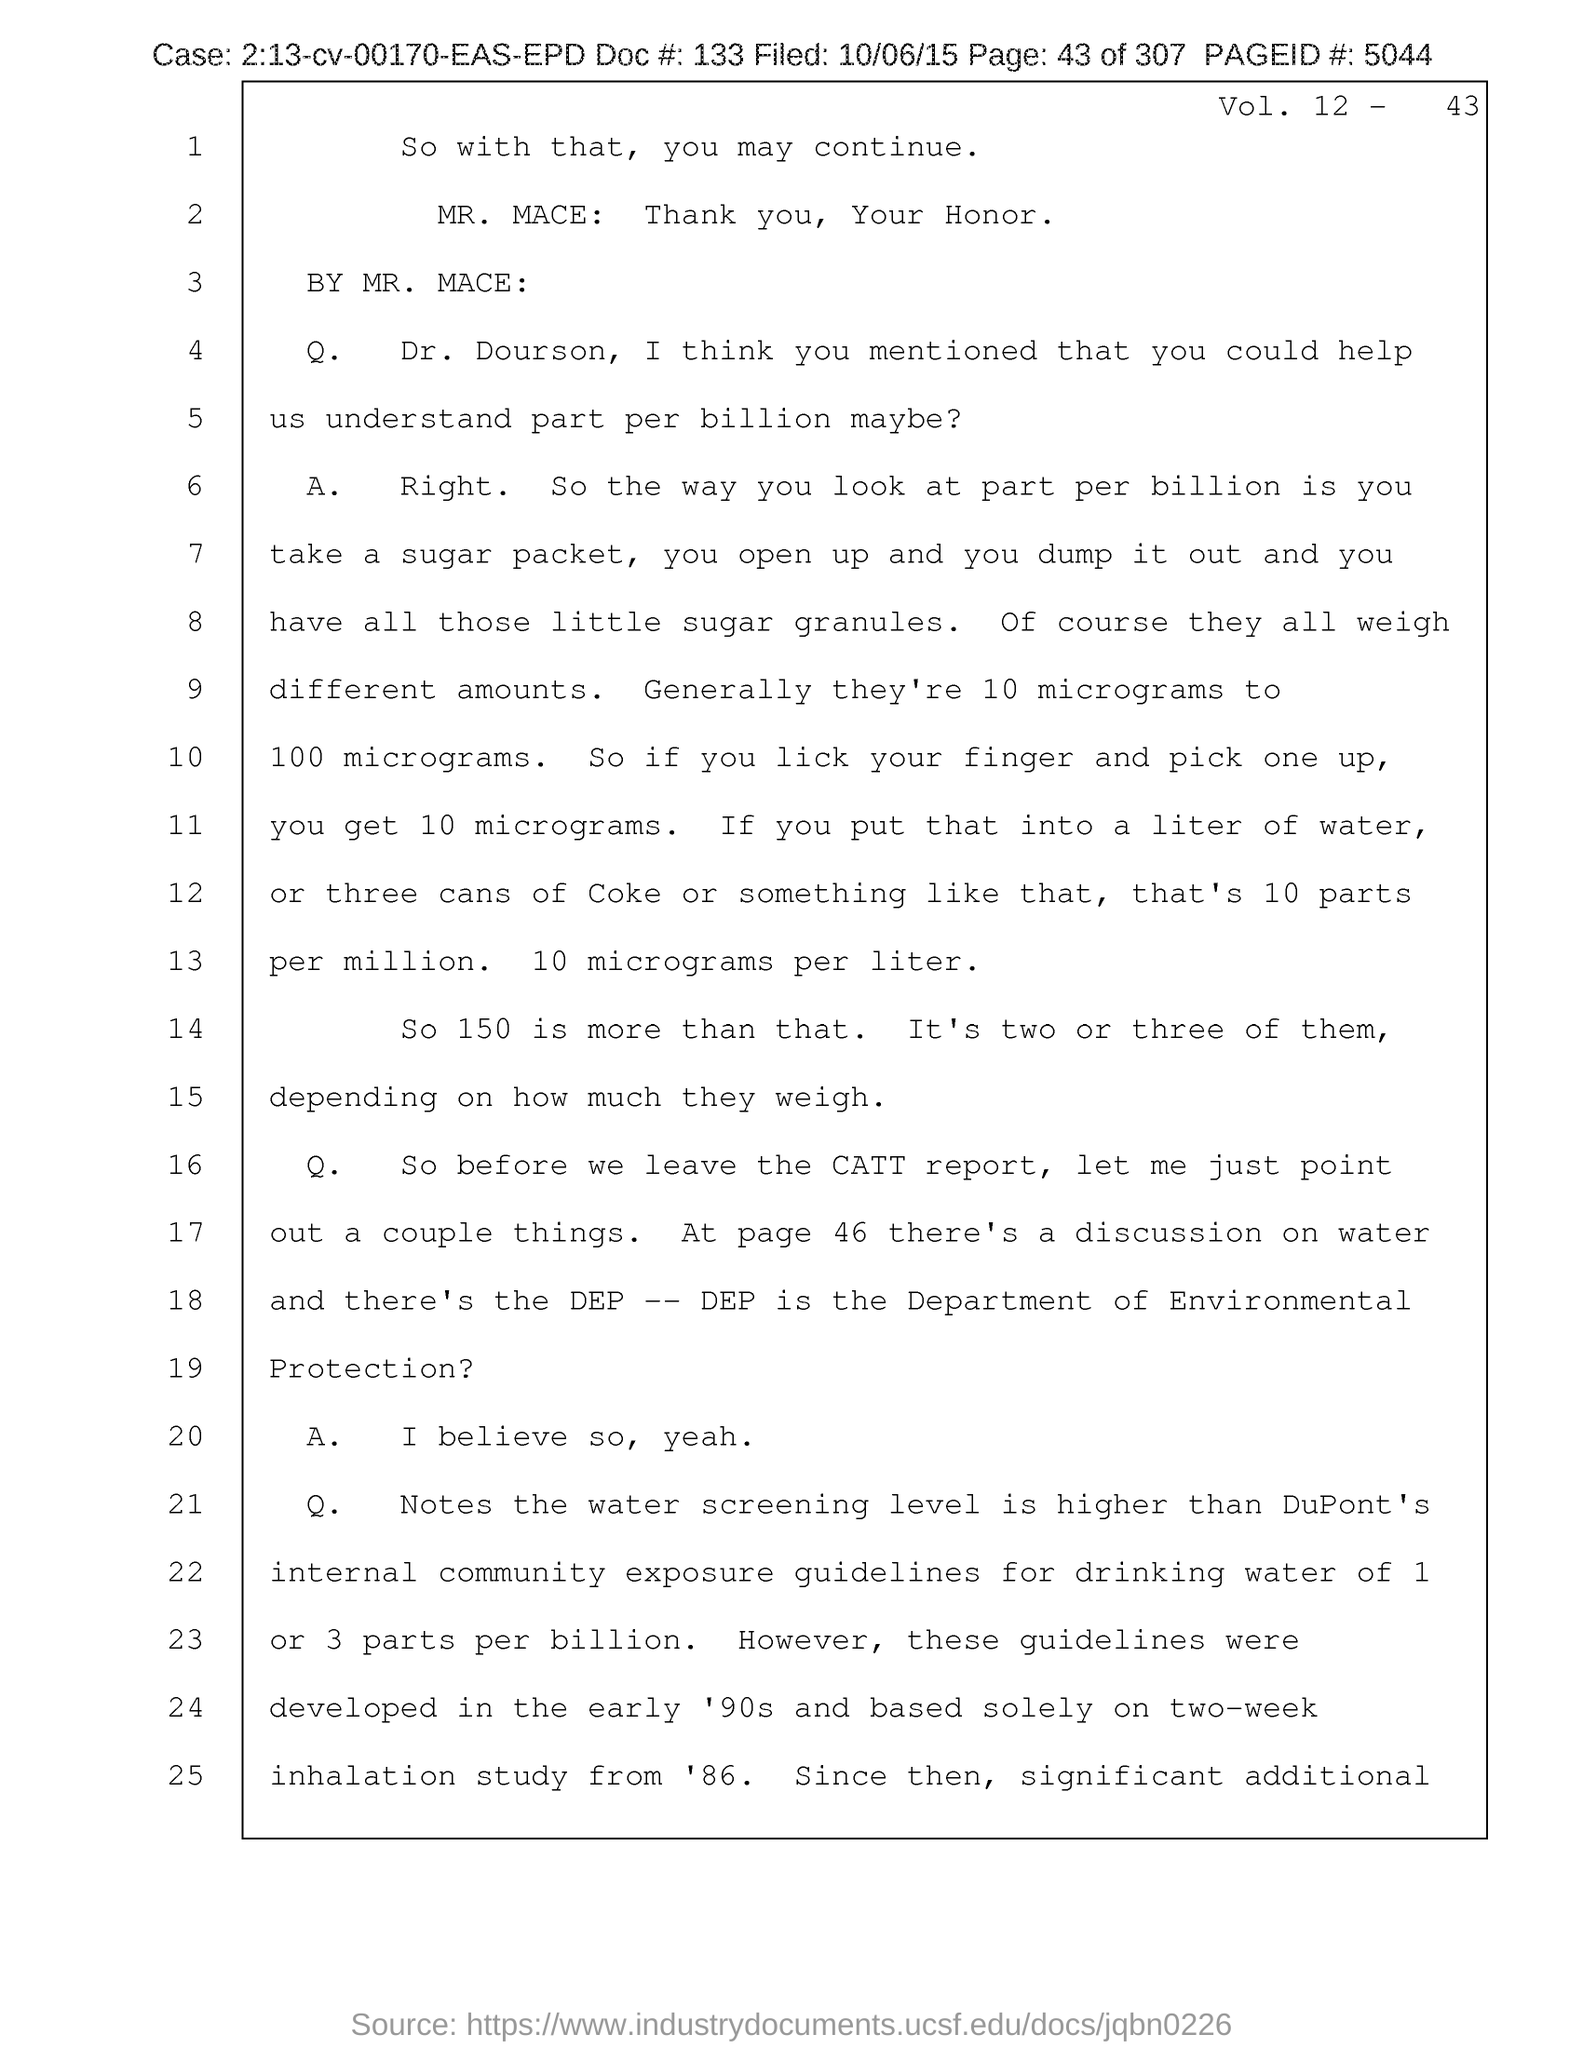Point out several critical features in this image. The person mentioned in the document starting with the letter 'M' is Mr. Mace. 